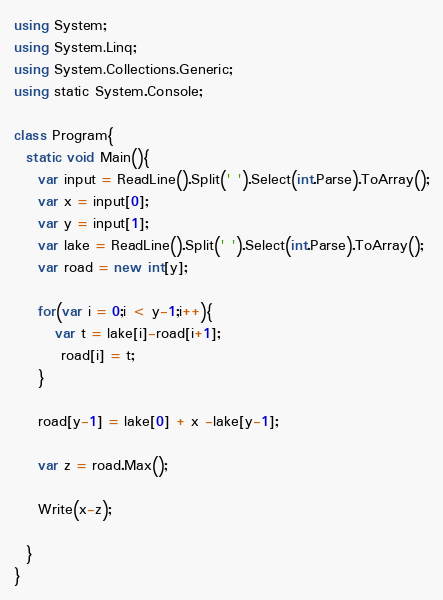<code> <loc_0><loc_0><loc_500><loc_500><_C#_>using System;
using System.Linq;
using System.Collections.Generic;
using static System.Console;

class Program{
  static void Main(){
	var input = ReadLine().Split(' ').Select(int.Parse).ToArray();
    var x = input[0];
    var y = input[1];
    var lake = ReadLine().Split(' ').Select(int.Parse).ToArray();
    var road = new int[y];
    
    for(var i = 0;i < y-1;i++){
       var t = lake[i]-road[i+1];
    	road[i] = t;
    }
    
    road[y-1] = lake[0] + x -lake[y-1];
    
    var z = road.Max();
    
    Write(x-z);
    
  }
}</code> 